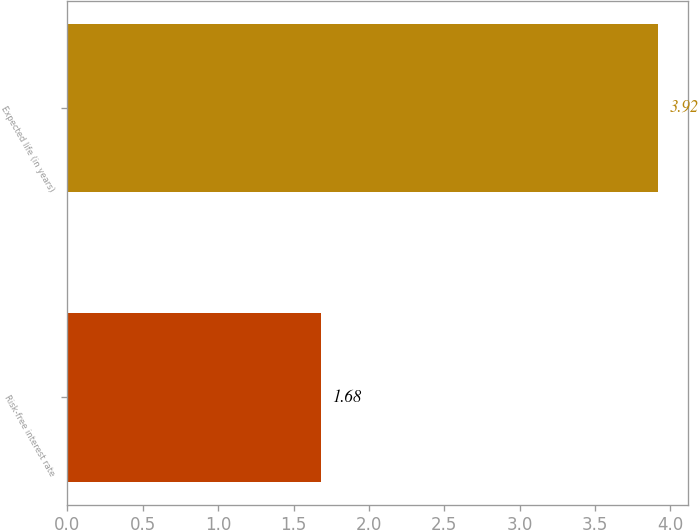Convert chart. <chart><loc_0><loc_0><loc_500><loc_500><bar_chart><fcel>Risk-free interest rate<fcel>Expected life (in years)<nl><fcel>1.68<fcel>3.92<nl></chart> 